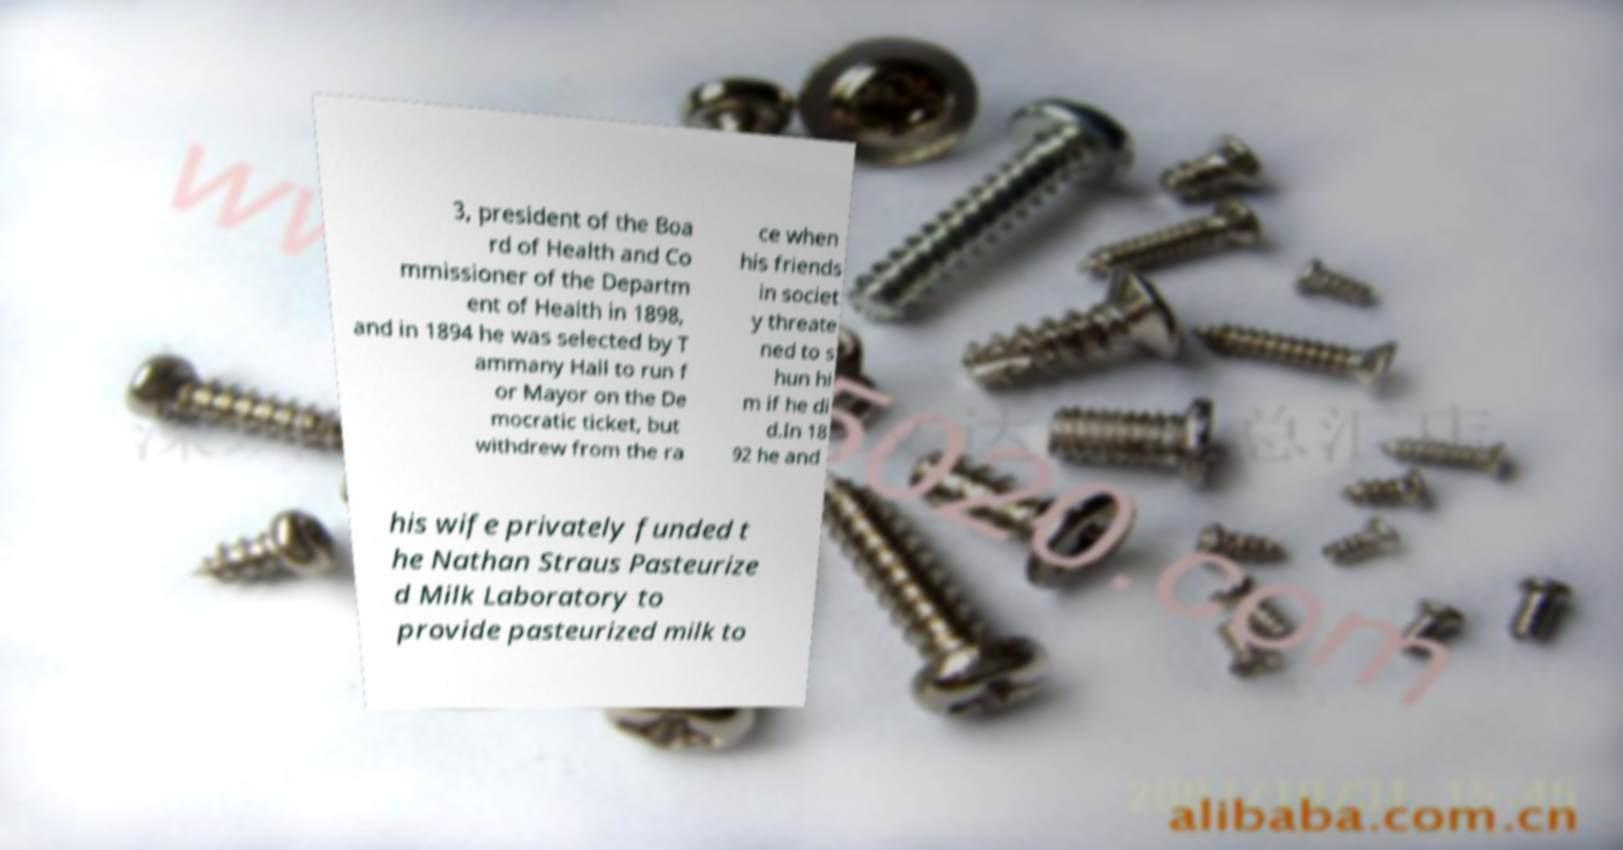Please identify and transcribe the text found in this image. 3, president of the Boa rd of Health and Co mmissioner of the Departm ent of Health in 1898, and in 1894 he was selected by T ammany Hall to run f or Mayor on the De mocratic ticket, but withdrew from the ra ce when his friends in societ y threate ned to s hun hi m if he di d.In 18 92 he and his wife privately funded t he Nathan Straus Pasteurize d Milk Laboratory to provide pasteurized milk to 